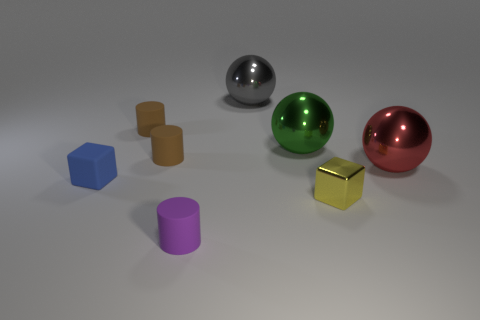Can you tell me which objects in the image are reflective? Certainly! In the image, the sphere second from the left has a reflective metallic surface, as does the sphere on the far right. The gold cube also exhibits a shiny, reflective surface. 